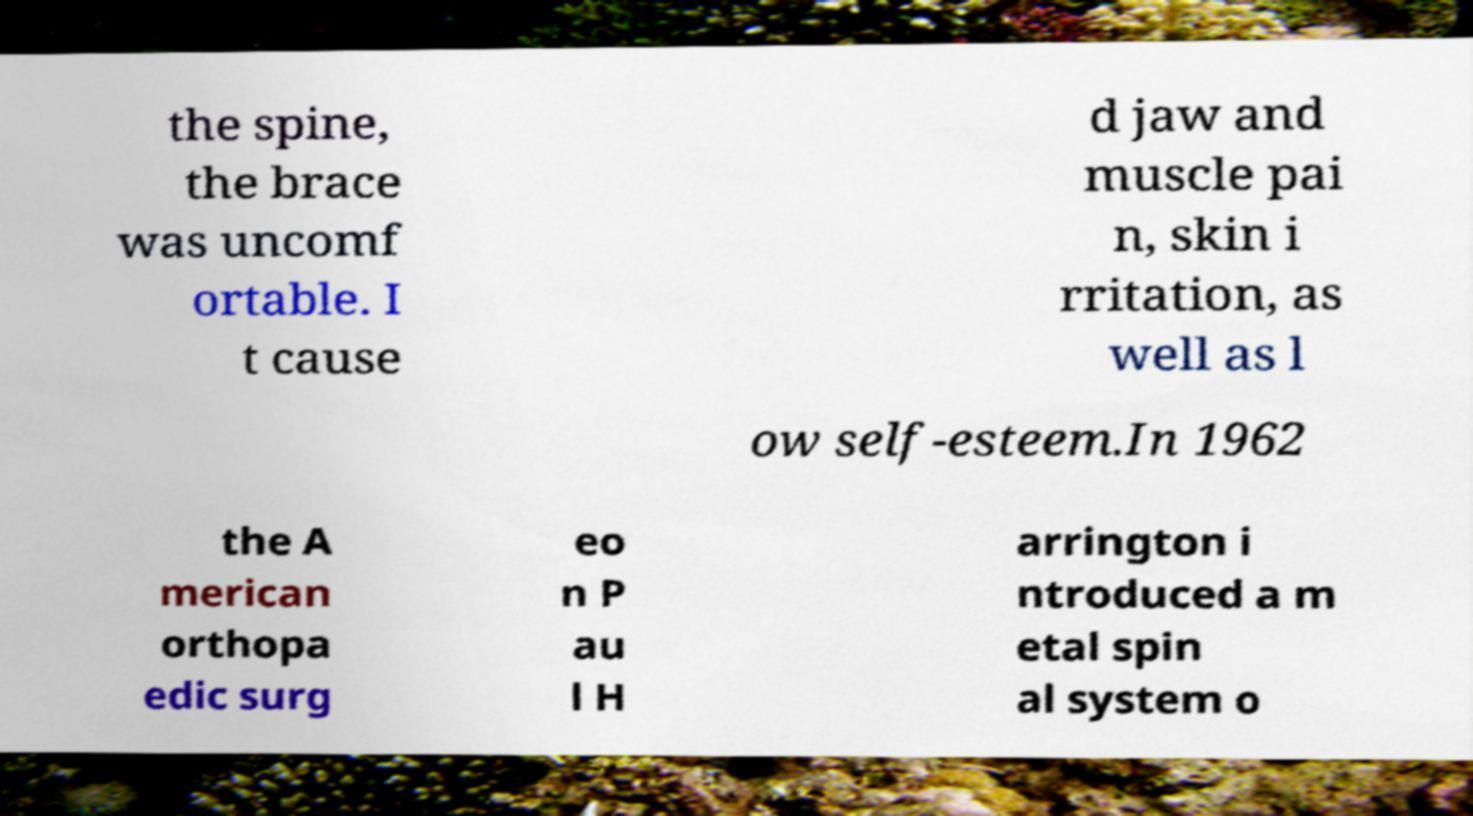Could you extract and type out the text from this image? the spine, the brace was uncomf ortable. I t cause d jaw and muscle pai n, skin i rritation, as well as l ow self-esteem.In 1962 the A merican orthopa edic surg eo n P au l H arrington i ntroduced a m etal spin al system o 